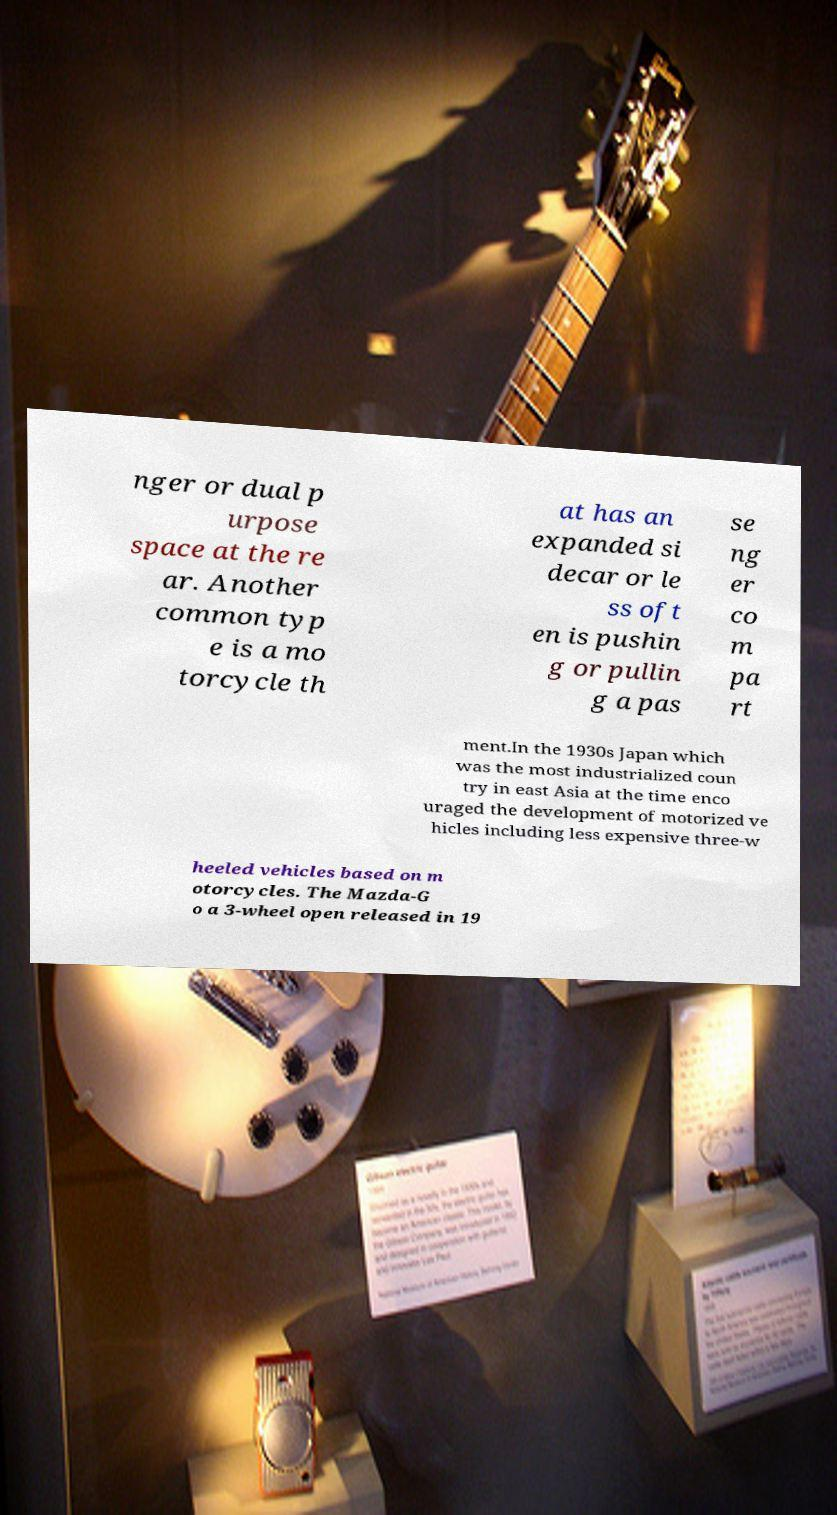Could you assist in decoding the text presented in this image and type it out clearly? nger or dual p urpose space at the re ar. Another common typ e is a mo torcycle th at has an expanded si decar or le ss oft en is pushin g or pullin g a pas se ng er co m pa rt ment.In the 1930s Japan which was the most industrialized coun try in east Asia at the time enco uraged the development of motorized ve hicles including less expensive three-w heeled vehicles based on m otorcycles. The Mazda-G o a 3-wheel open released in 19 